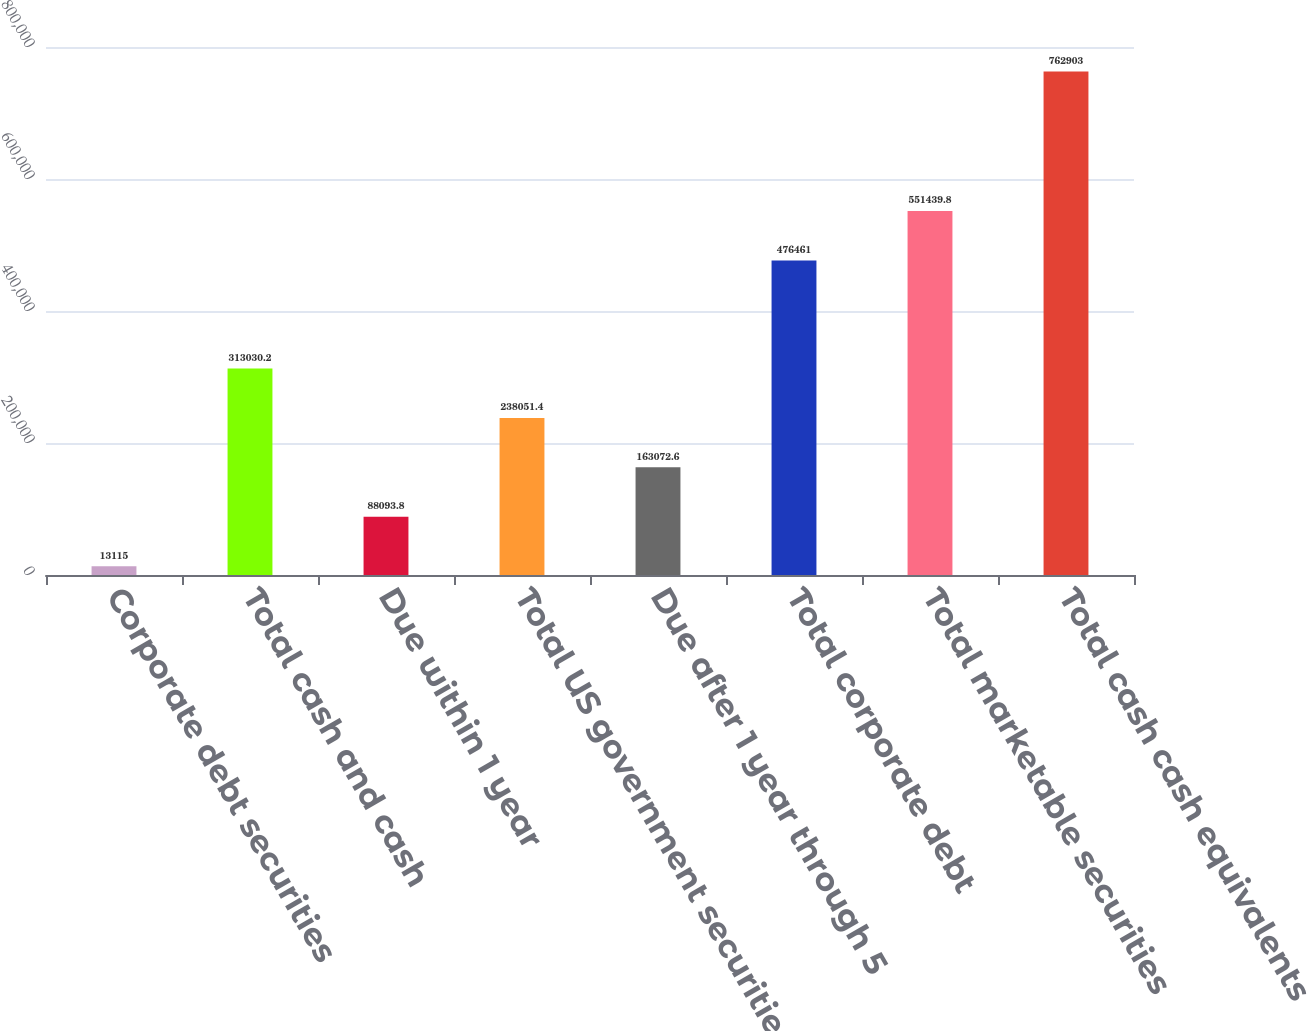Convert chart. <chart><loc_0><loc_0><loc_500><loc_500><bar_chart><fcel>Corporate debt securities<fcel>Total cash and cash<fcel>Due within 1 year<fcel>Total US government securities<fcel>Due after 1 year through 5<fcel>Total corporate debt<fcel>Total marketable securities<fcel>Total cash cash equivalents<nl><fcel>13115<fcel>313030<fcel>88093.8<fcel>238051<fcel>163073<fcel>476461<fcel>551440<fcel>762903<nl></chart> 